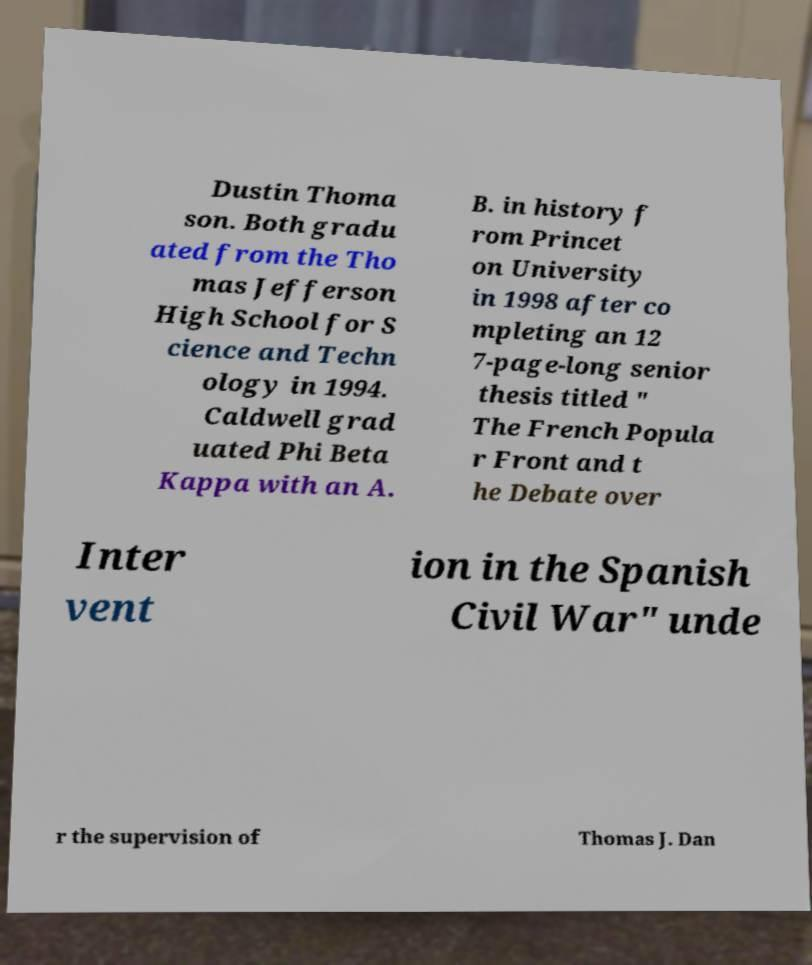Can you accurately transcribe the text from the provided image for me? Dustin Thoma son. Both gradu ated from the Tho mas Jefferson High School for S cience and Techn ology in 1994. Caldwell grad uated Phi Beta Kappa with an A. B. in history f rom Princet on University in 1998 after co mpleting an 12 7-page-long senior thesis titled " The French Popula r Front and t he Debate over Inter vent ion in the Spanish Civil War" unde r the supervision of Thomas J. Dan 